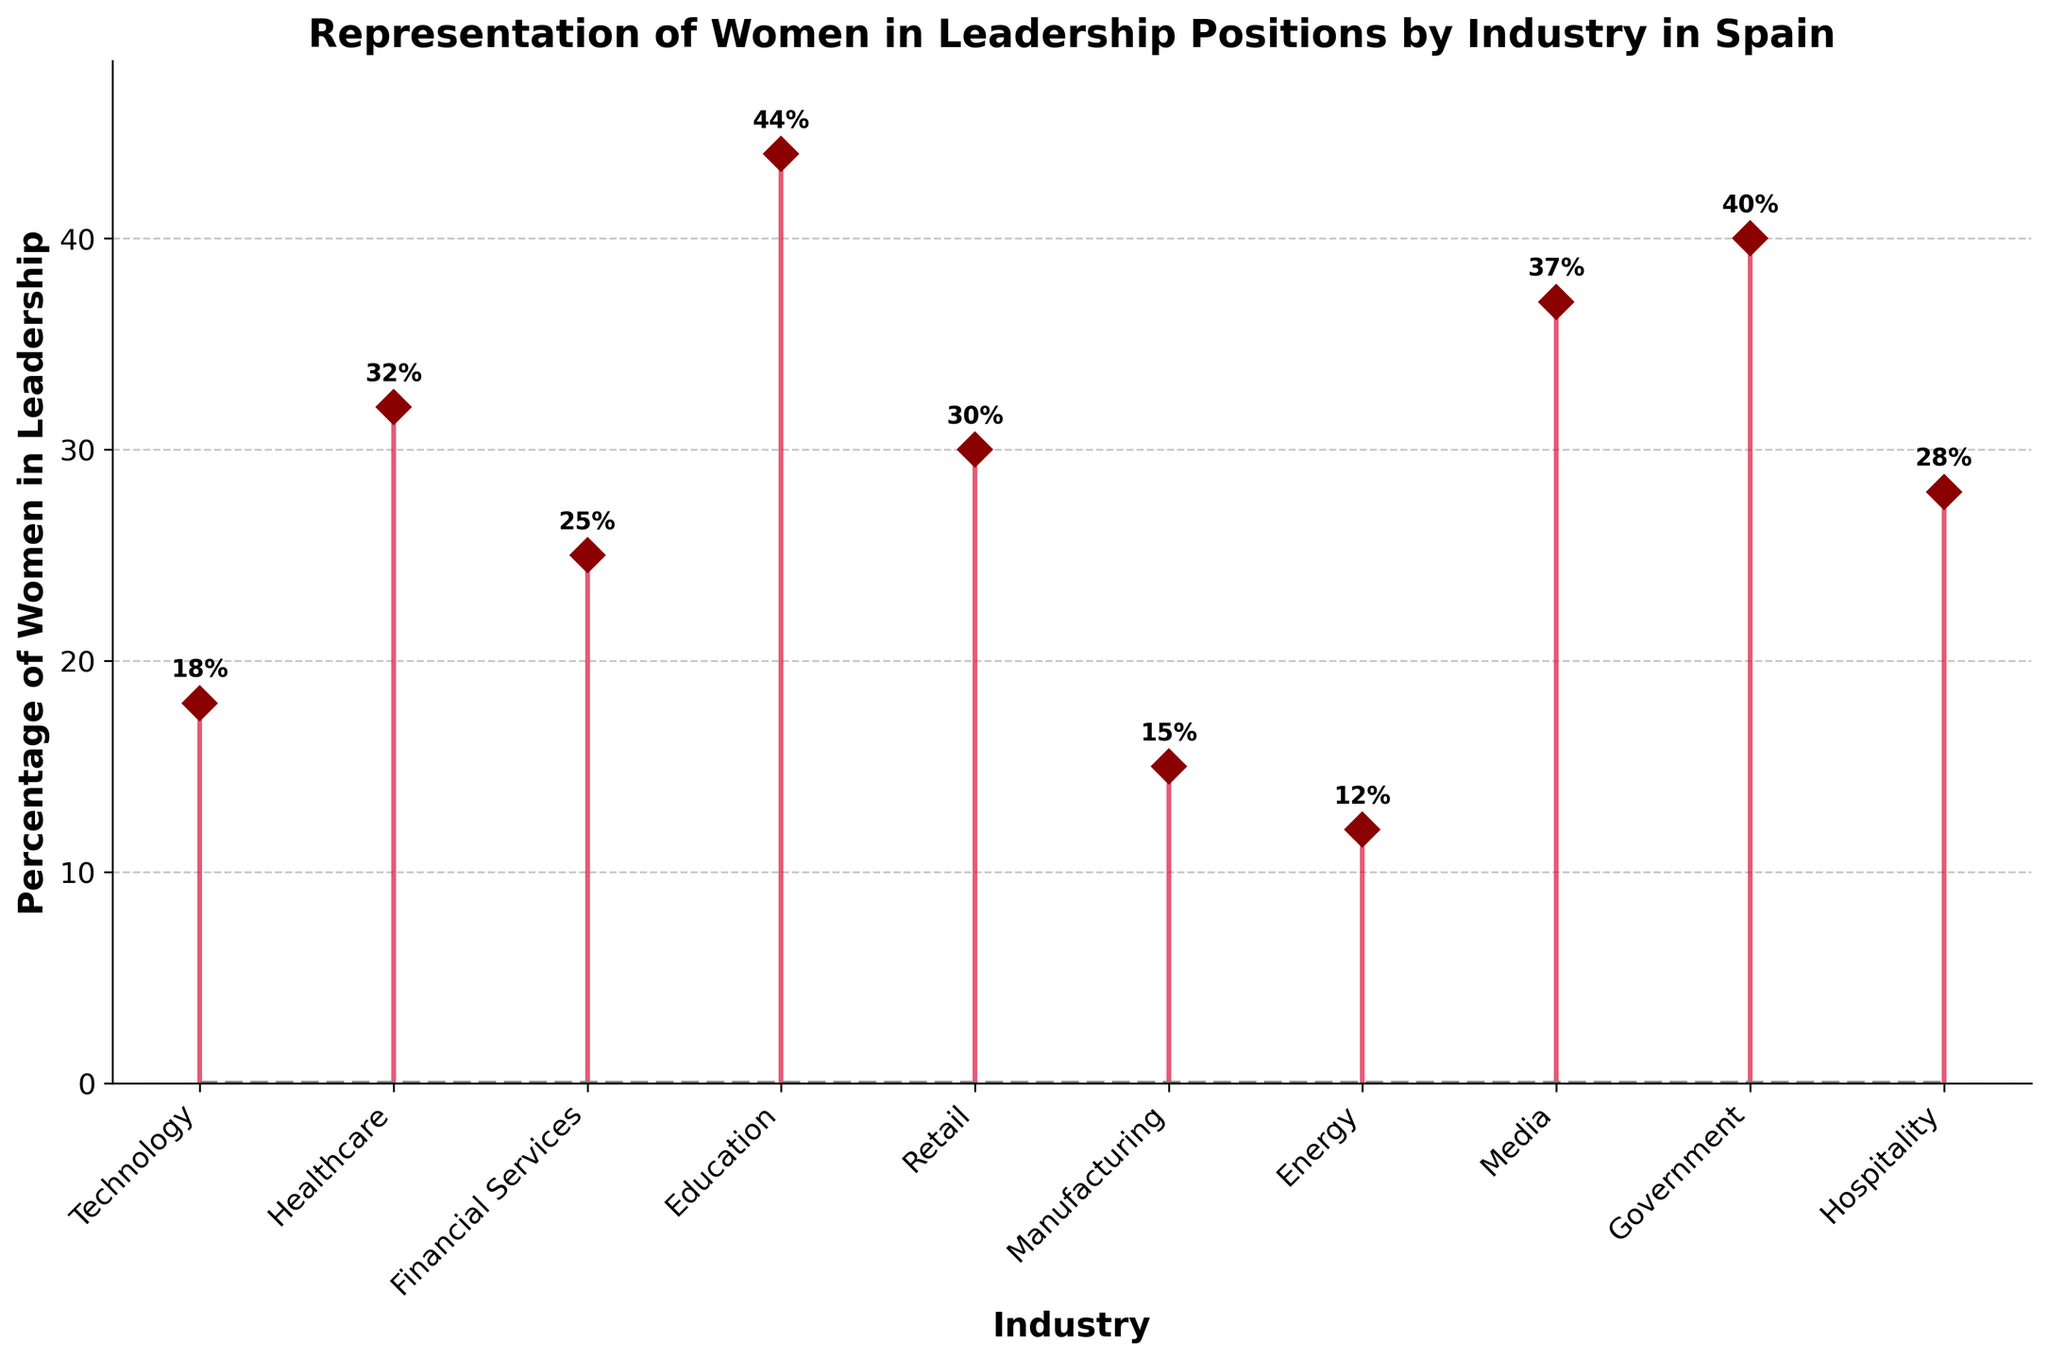What is the title of the plot? The title of the plot is prominently displayed at the top and reads, "Representation of Women in Leadership Positions by Industry in Spain".
Answer: Representation of Women in Leadership Positions by Industry in Spain What is the industry with the highest percentage of women in leadership? The industry with the highest value, marked with the tallest stem and the value annotation at the top, is Education with 44%.
Answer: Education How many industries have a percentage of women in leadership above 30%? By counting the stems higher than 30% and annotated with values above 30%, the industries are: Healthcare, Education, Media, Government, totaling 4.
Answer: 4 Which industry has the lowest percentage of women in leadership, and what is it? The industry with the shortest stem and the lowest value annotation is Energy with 12%.
Answer: Energy, 12% What is the average percentage of women in leadership across all listed industries? Sum all the given percentages: (18 + 32 + 25 + 44 + 30 + 15 + 12 + 37 + 40 + 28) = 281, and divide by the number of industries, which is 10. So, 281 / 10 = 28.1%.
Answer: 28.1% What is the difference in the percentage of women in leadership between Government and Media industries? Government's percentage is 40%, and Media's percentage is 37%. The difference is 40 - 37 = 3%.
Answer: 3% Which industry has a percentage of women in leadership almost equal to double that of Technology? Technology has 18%. Double of 18% is 36%, and Media has 37%, closest to double of Technology.
Answer: Media What is the total percentage of women in leadership if you combine Financial Services, Retail, and Hospitality? Sum the given percentages for Financial Services (25%), Retail (30%), and Hospitality (28%). The total is 25 + 30 + 28 = 83%.
Answer: 83% Compare the representation of women in leadership between Technology and Manufacturing. Which one has a higher percentage and by how much? Technology has 18%, and Manufacturing has 15%. The difference is 18 - 15 = 3%. Technology has a higher percentage by 3%.
Answer: Technology, higher by 3% What percentage more women are in leadership in Healthcare compared to Manufacturing? Healthcare's percentage is 32%, and Manufacturing's percentage is 15%. The difference is 32 - 15 = 17%.
Answer: 17% بیشتر 